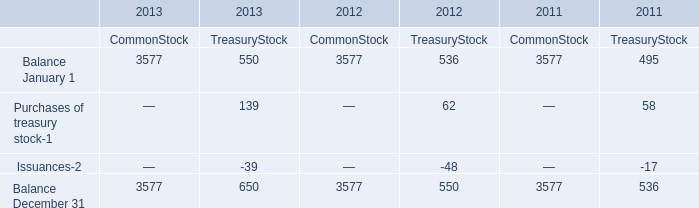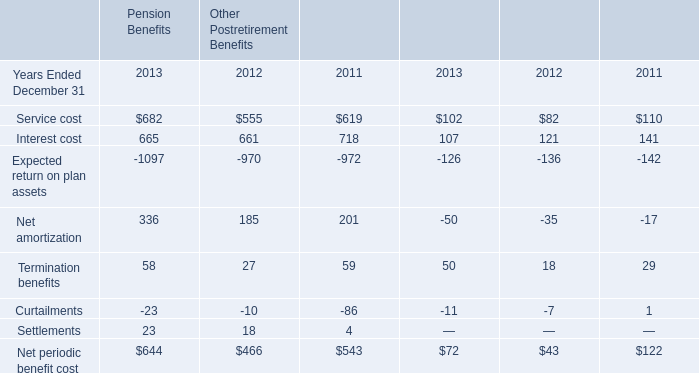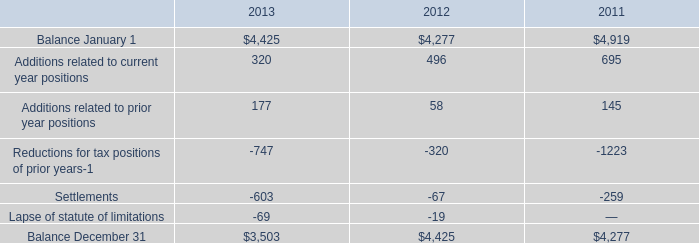what's the total amount of Balance January 1 of 2011 CommonStock, and Reductions for tax positions of prior years of 2011 ? 
Computations: (3577.0 + 1223.0)
Answer: 4800.0. 